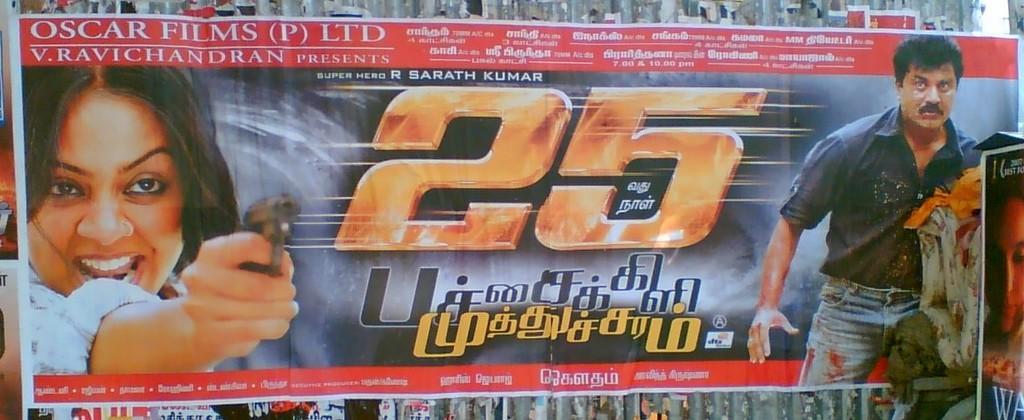How would you summarize this image in a sentence or two? In the center of the image there is a poster on the wall. There are depictions of person and some text on it. 